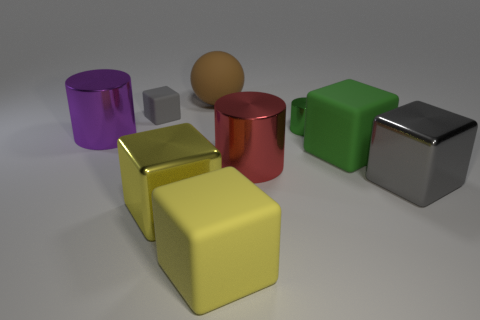Subtract 1 blocks. How many blocks are left? 4 Subtract all big yellow matte cubes. How many cubes are left? 4 Subtract all blue cubes. Subtract all gray spheres. How many cubes are left? 5 Add 1 big shiny cubes. How many objects exist? 10 Subtract all blocks. How many objects are left? 4 Subtract 0 yellow spheres. How many objects are left? 9 Subtract all green matte objects. Subtract all big yellow rubber cubes. How many objects are left? 7 Add 6 big matte objects. How many big matte objects are left? 9 Add 2 large gray blocks. How many large gray blocks exist? 3 